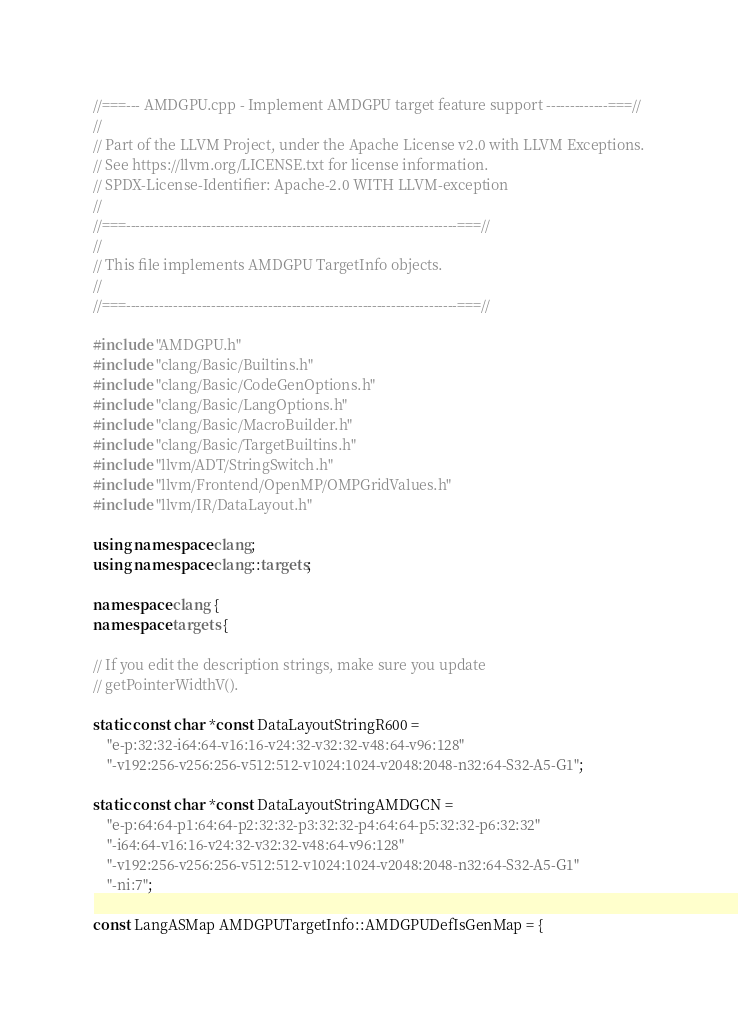<code> <loc_0><loc_0><loc_500><loc_500><_C++_>//===--- AMDGPU.cpp - Implement AMDGPU target feature support -------------===//
//
// Part of the LLVM Project, under the Apache License v2.0 with LLVM Exceptions.
// See https://llvm.org/LICENSE.txt for license information.
// SPDX-License-Identifier: Apache-2.0 WITH LLVM-exception
//
//===----------------------------------------------------------------------===//
//
// This file implements AMDGPU TargetInfo objects.
//
//===----------------------------------------------------------------------===//

#include "AMDGPU.h"
#include "clang/Basic/Builtins.h"
#include "clang/Basic/CodeGenOptions.h"
#include "clang/Basic/LangOptions.h"
#include "clang/Basic/MacroBuilder.h"
#include "clang/Basic/TargetBuiltins.h"
#include "llvm/ADT/StringSwitch.h"
#include "llvm/Frontend/OpenMP/OMPGridValues.h"
#include "llvm/IR/DataLayout.h"

using namespace clang;
using namespace clang::targets;

namespace clang {
namespace targets {

// If you edit the description strings, make sure you update
// getPointerWidthV().

static const char *const DataLayoutStringR600 =
    "e-p:32:32-i64:64-v16:16-v24:32-v32:32-v48:64-v96:128"
    "-v192:256-v256:256-v512:512-v1024:1024-v2048:2048-n32:64-S32-A5-G1";

static const char *const DataLayoutStringAMDGCN =
    "e-p:64:64-p1:64:64-p2:32:32-p3:32:32-p4:64:64-p5:32:32-p6:32:32"
    "-i64:64-v16:16-v24:32-v32:32-v48:64-v96:128"
    "-v192:256-v256:256-v512:512-v1024:1024-v2048:2048-n32:64-S32-A5-G1"
    "-ni:7";

const LangASMap AMDGPUTargetInfo::AMDGPUDefIsGenMap = {</code> 